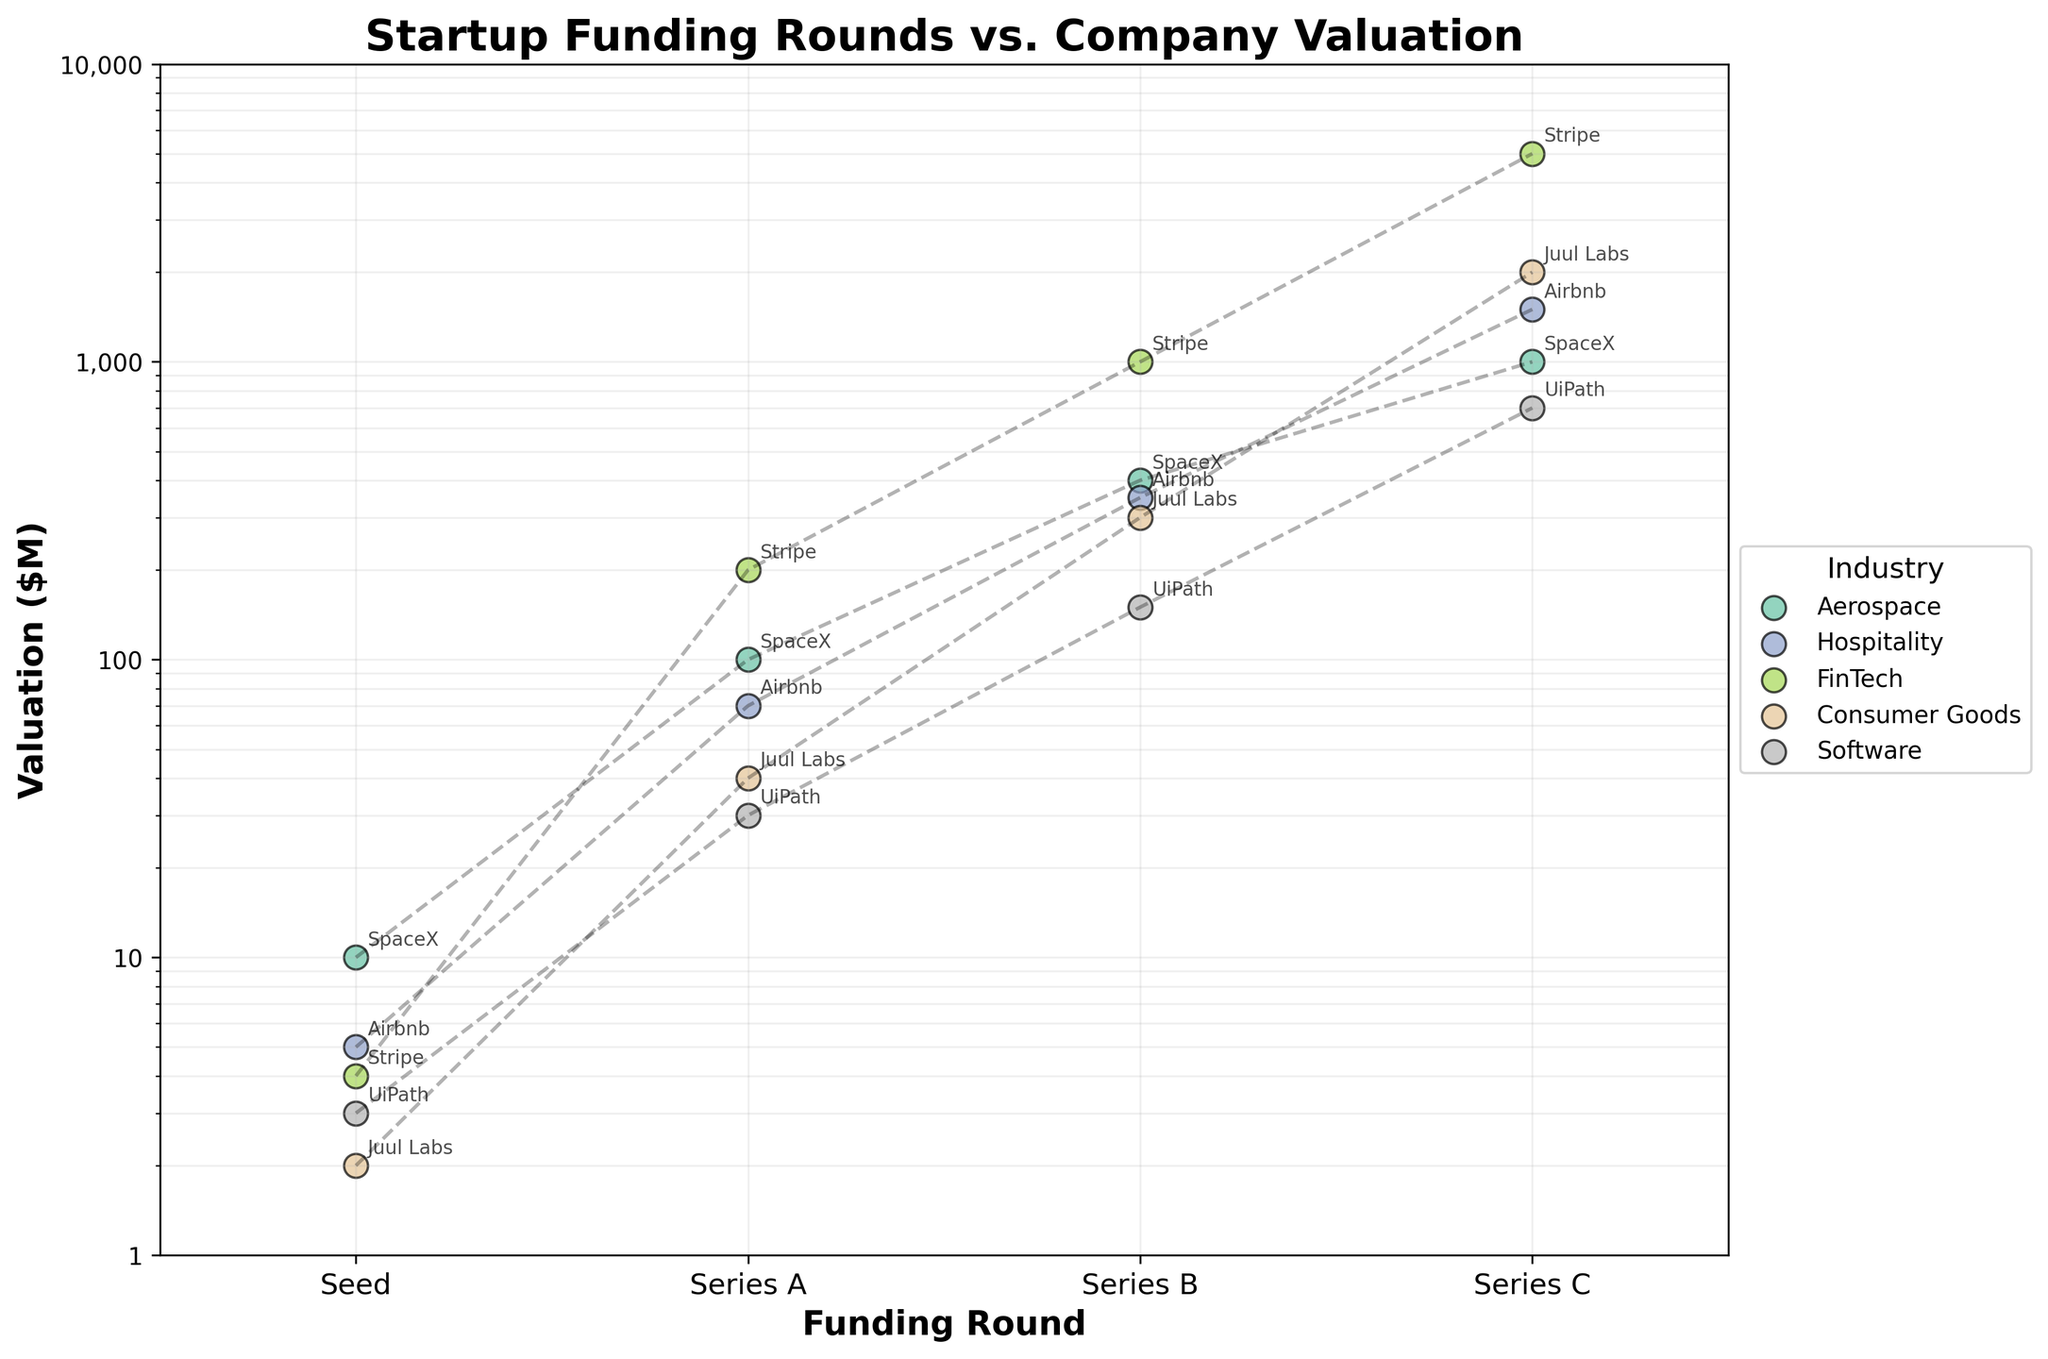What is the title of the plot? The title is usually the first piece of text you see at the top of the graph. Here, it is in a bold font and clearly states what the chart represents.
Answer: Startup Funding Rounds vs. Company Valuation How many industries are represented in the plot? Each unique industry is represented by a distinct color in the legend. Counting these colors will give the number of industries.
Answer: 5 Which industry has companies with the highest valuations in Series C funding round? To answer, identify the 'Series C' column on the x-axis, and then look for the highest data points within that column, and cross-check with their corresponding industry colors and labels.
Answer: Hospitality What's the median valuation in the Seed funding round? Extract all the valuation points within the 'Seed' funding column, list them (2, 3, 4, 5, 10), and find the middle value which is the median.
Answer: 4 Which company shows the largest jump in valuation from Series A to Series B? Compare the differences in valuation between Series A and Series B for each company. Identify the highest increment by calculating the differences (SpaceX: 300, Airbnb: 280, Stripe: 800, Juul Labs: 260, UiPath: 120).
Answer: Stripe Are there any companies whose valuation decreased in any of the funding rounds? Trace each company's valuation trajectory through the funding rounds visually. A decrease would show as a downward trend in any segment.
Answer: No Which funding round has the highest average valuation across all industries? Calculate the average valuation for each funding round by adding all valuations in that round and dividing by the number of companies, then compare these averages. (Seed: 4.8, Series A: 88, Series B: 440, Series C: 2040).
Answer: Series C How does the valuation of Juul Labs in Series C compare to the valuation of Stripe in Series B? Locate the valuations for Juul Labs in Series C (2000) and Stripe in Series B (1000) and perform a direct comparison.
Answer: Higher What's the valuation range for the Software industry across all funding rounds? Identify the minimum (3) and maximum (700) valuations within the Software category by inspecting the range of Software's dots across all columns.
Answer: 3 to 700 